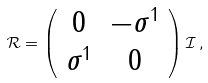Convert formula to latex. <formula><loc_0><loc_0><loc_500><loc_500>\mathcal { R } = \left ( \begin{array} { c c } 0 & - \sigma ^ { 1 } \\ \sigma ^ { 1 } & 0 \\ \end{array} \right ) \mathcal { I } \, ,</formula> 